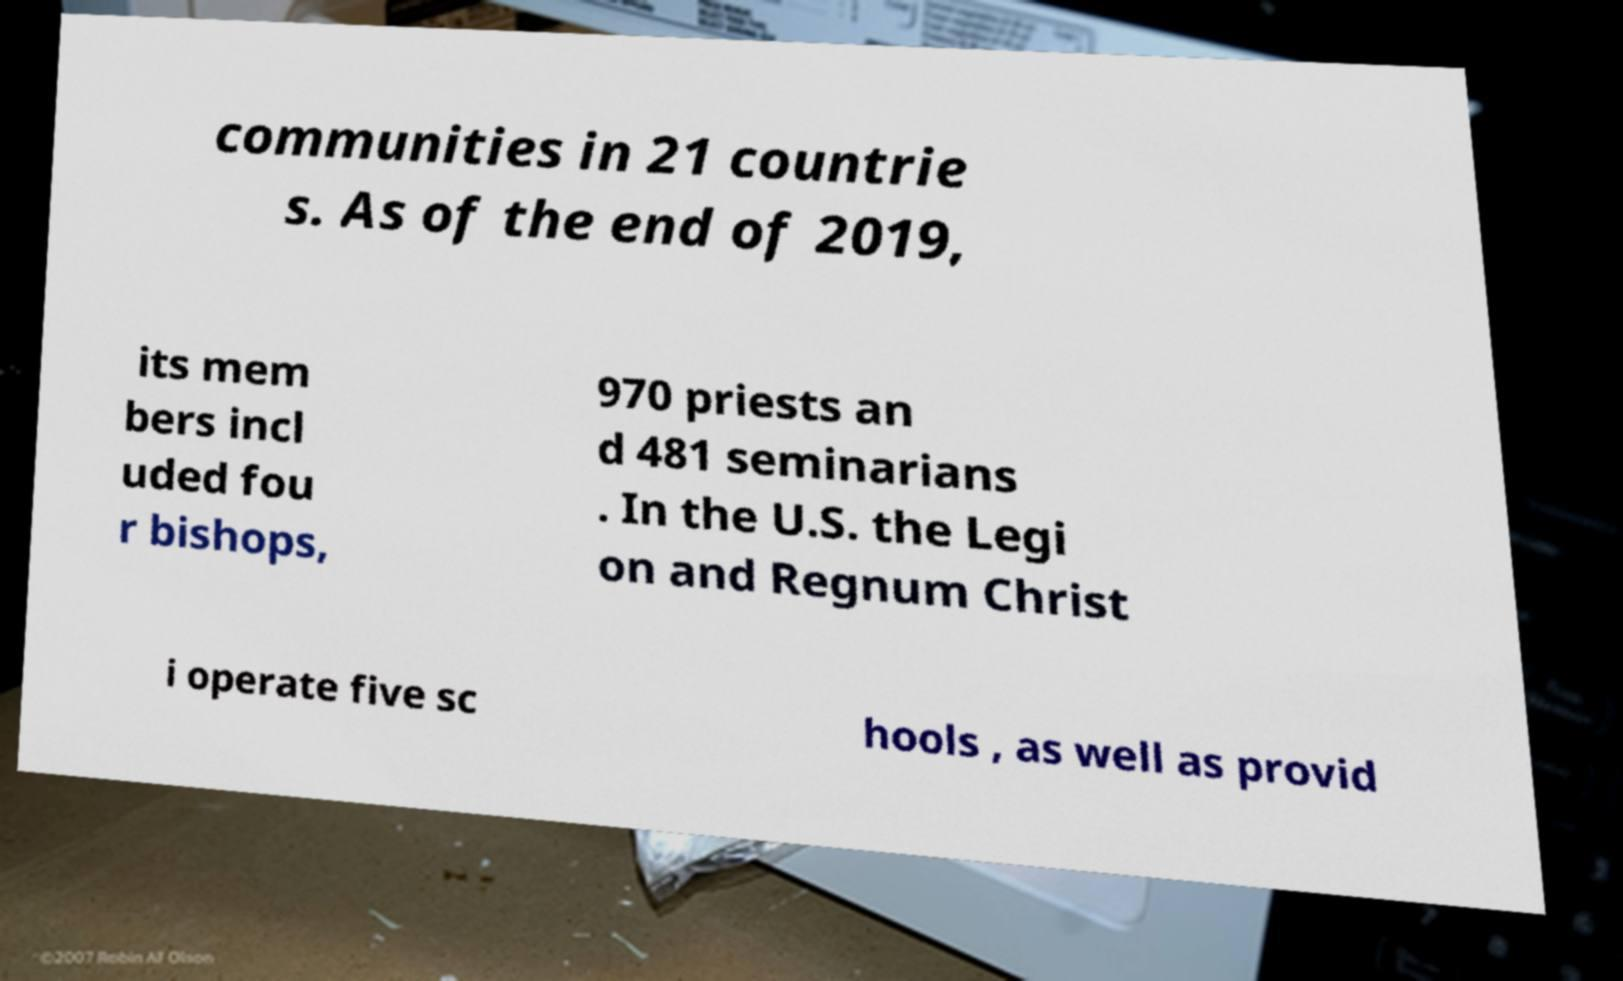What messages or text are displayed in this image? I need them in a readable, typed format. communities in 21 countrie s. As of the end of 2019, its mem bers incl uded fou r bishops, 970 priests an d 481 seminarians . In the U.S. the Legi on and Regnum Christ i operate five sc hools , as well as provid 